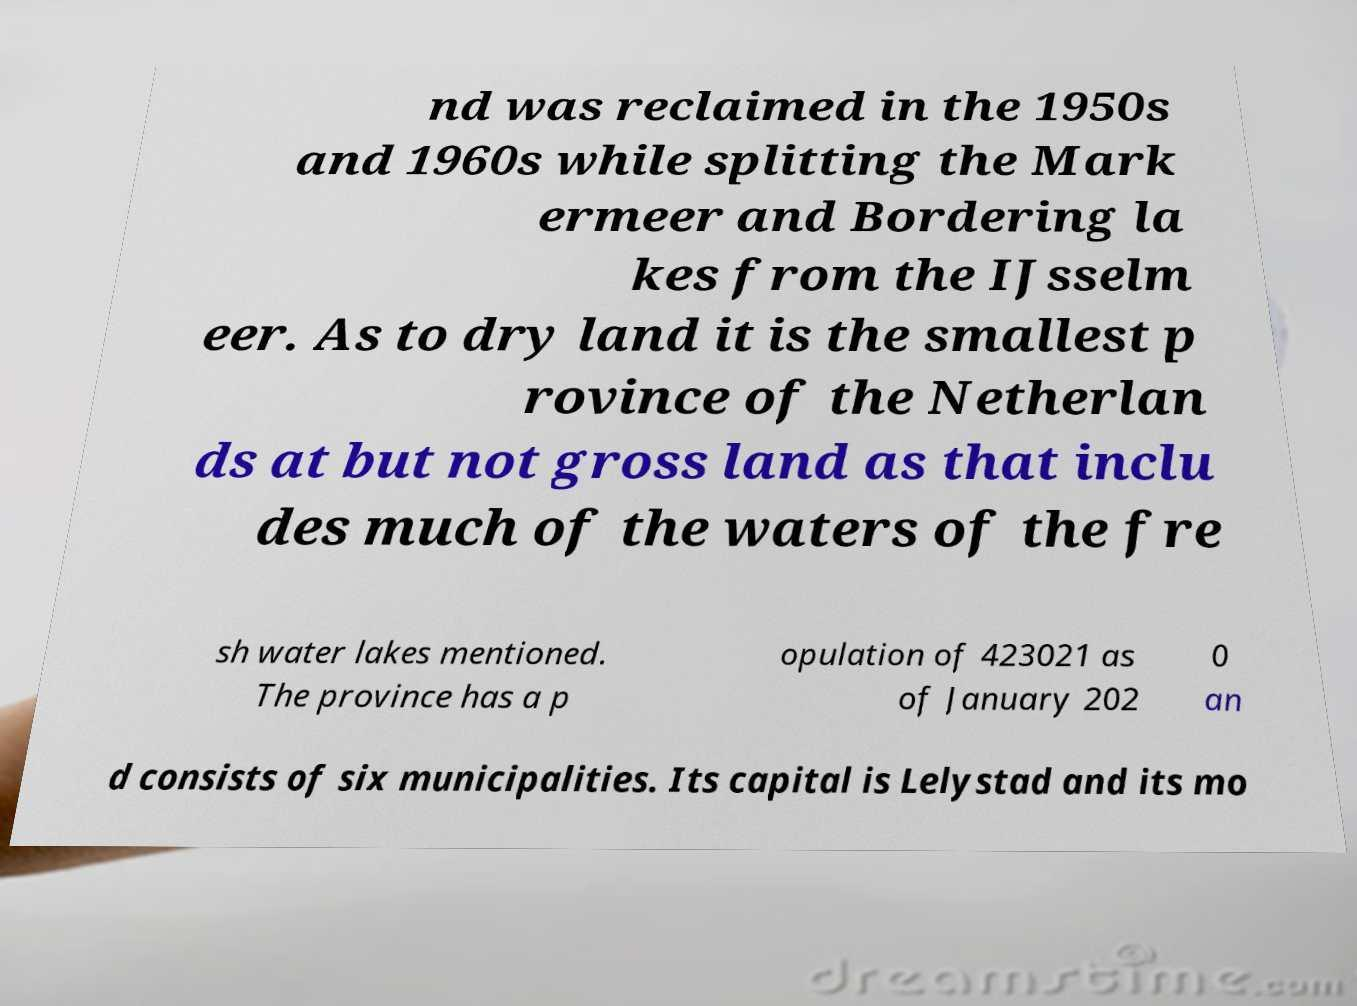I need the written content from this picture converted into text. Can you do that? nd was reclaimed in the 1950s and 1960s while splitting the Mark ermeer and Bordering la kes from the IJsselm eer. As to dry land it is the smallest p rovince of the Netherlan ds at but not gross land as that inclu des much of the waters of the fre sh water lakes mentioned. The province has a p opulation of 423021 as of January 202 0 an d consists of six municipalities. Its capital is Lelystad and its mo 